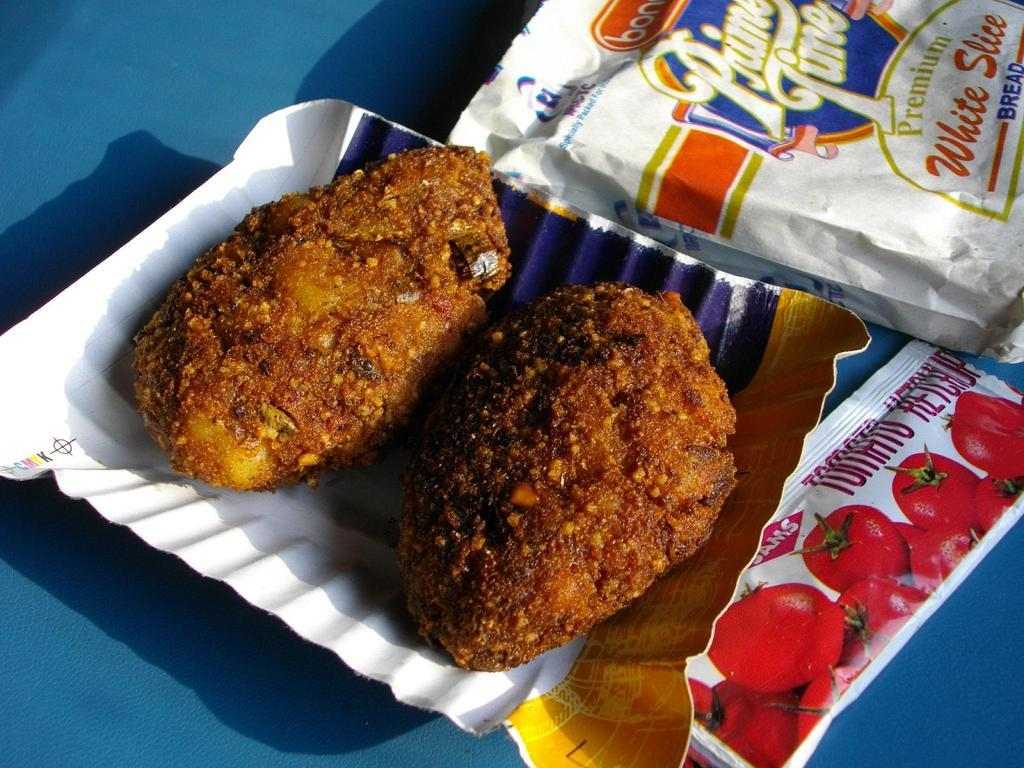What is on the paper plate in the image? The paper plate contains food. What else can be seen on the right side of the image besides the paper plate? There are packets on the right side of the image. How many eggs are visible in the image? There are no eggs present in the image. Is there a water source visible in the image? There is no water source visible in the image. 